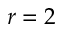<formula> <loc_0><loc_0><loc_500><loc_500>r = 2</formula> 